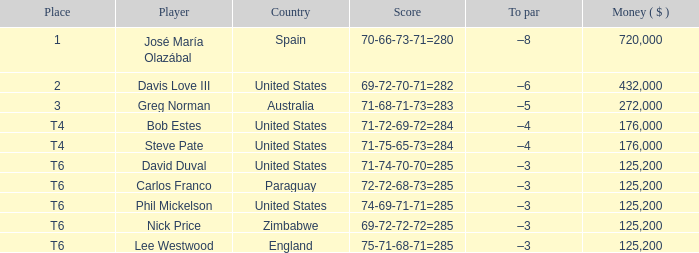Which average money has a Score of 69-72-72-72=285? 125200.0. 